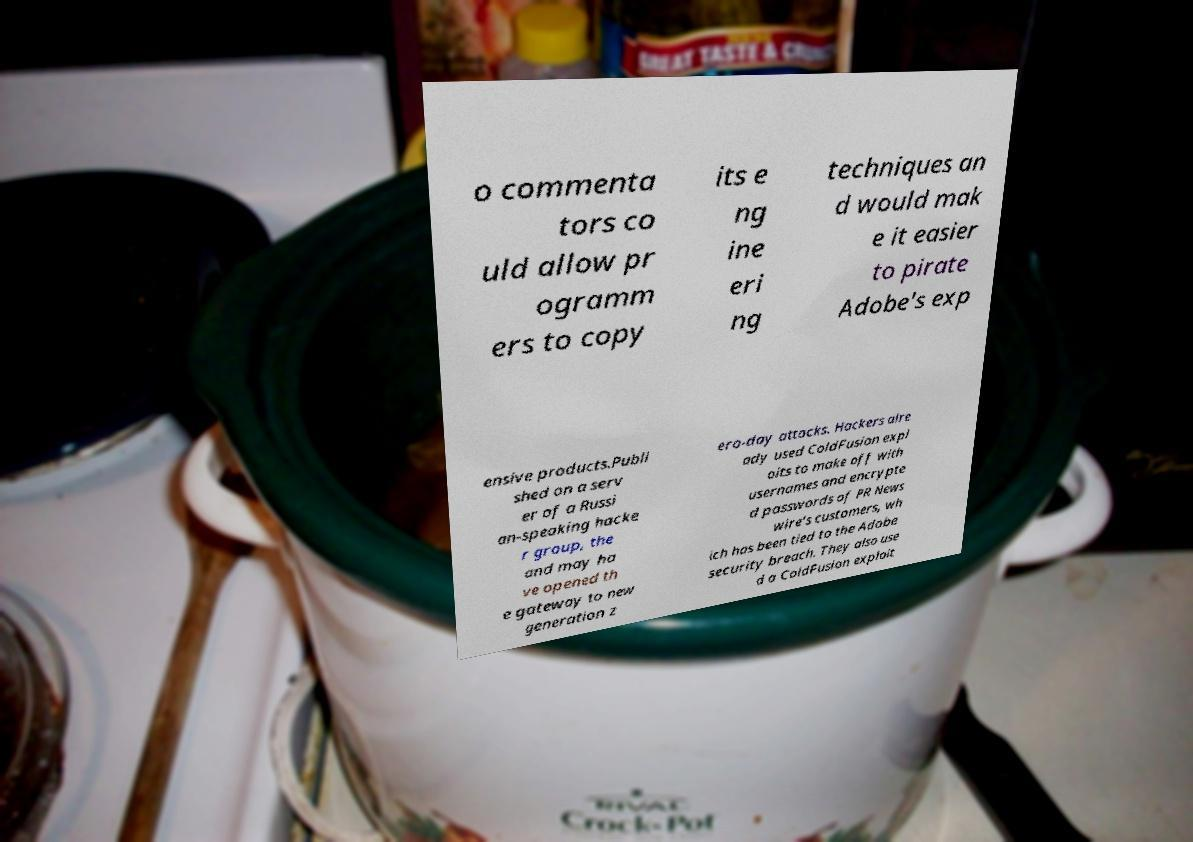Could you extract and type out the text from this image? o commenta tors co uld allow pr ogramm ers to copy its e ng ine eri ng techniques an d would mak e it easier to pirate Adobe's exp ensive products.Publi shed on a serv er of a Russi an-speaking hacke r group, the and may ha ve opened th e gateway to new generation z ero-day attacks. Hackers alre ady used ColdFusion expl oits to make off with usernames and encrypte d passwords of PR News wire's customers, wh ich has been tied to the Adobe security breach. They also use d a ColdFusion exploit 